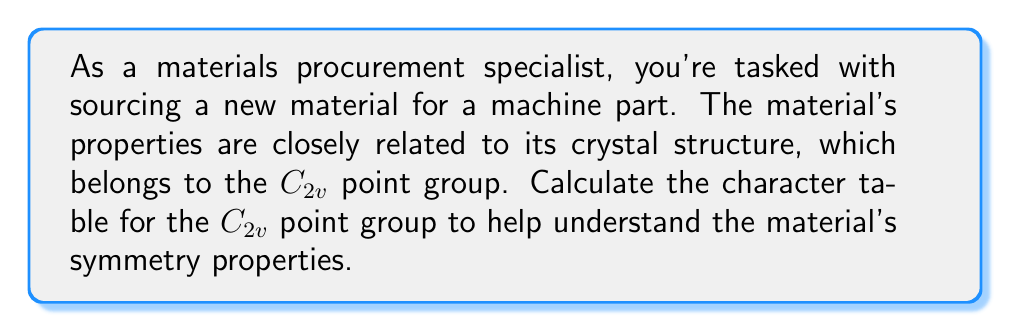Teach me how to tackle this problem. To calculate the character table for the $C_{2v}$ point group, we'll follow these steps:

1. Identify the symmetry operations:
   - $E$: identity
   - $C_2$: rotation by 180°
   - $\sigma_v(xz)$: reflection in xz plane
   - $\sigma_v'(yz)$: reflection in yz plane

2. Determine the number of classes:
   There are 4 classes, each containing one operation.

3. Identify the number of irreducible representations:
   The number of irreducible representations equals the number of classes, so there are 4.

4. Use the orthogonality theorem to determine the dimensions of the irreducible representations:
   $\sum_i (d_i)^2 = |G|$, where $d_i$ are the dimensions and $|G|$ is the order of the group.
   $1^2 + 1^2 + 1^2 + 1^2 = 4$, so all irreducible representations are 1-dimensional.

5. Construct the character table:
   a. The first row (totally symmetric representation) is always all 1's.
   b. The second row alternates 1 and -1, starting with 1.
   c. The third row has 1 for $E$ and $\sigma_v(xz)$, and -1 for $C_2$ and $\sigma_v'(yz)$.
   d. The fourth row has 1 for $E$ and $\sigma_v'(yz)$, and -1 for $C_2$ and $\sigma_v(xz)$.

6. Label the irreducible representations:
   - $A_1$: totally symmetric
   - $A_2$: antisymmetric to both reflections
   - $B_1$: symmetric to $\sigma_v(xz)$, antisymmetric to $\sigma_v'(yz)$
   - $B_2$: antisymmetric to $\sigma_v(xz)$, symmetric to $\sigma_v'(yz)$

The resulting character table is:

$$
\begin{array}{c|cccc}
C_{2v} & E & C_2 & \sigma_v(xz) & \sigma_v'(yz) \\
\hline
A_1 & 1 & 1 & 1 & 1 \\
A_2 & 1 & 1 & -1 & -1 \\
B_1 & 1 & -1 & 1 & -1 \\
B_2 & 1 & -1 & -1 & 1
\end{array}
$$
Answer: $$
\begin{array}{c|cccc}
C_{2v} & E & C_2 & \sigma_v(xz) & \sigma_v'(yz) \\
\hline
A_1 & 1 & 1 & 1 & 1 \\
A_2 & 1 & 1 & -1 & -1 \\
B_1 & 1 & -1 & 1 & -1 \\
B_2 & 1 & -1 & -1 & 1
\end{array}
$$ 